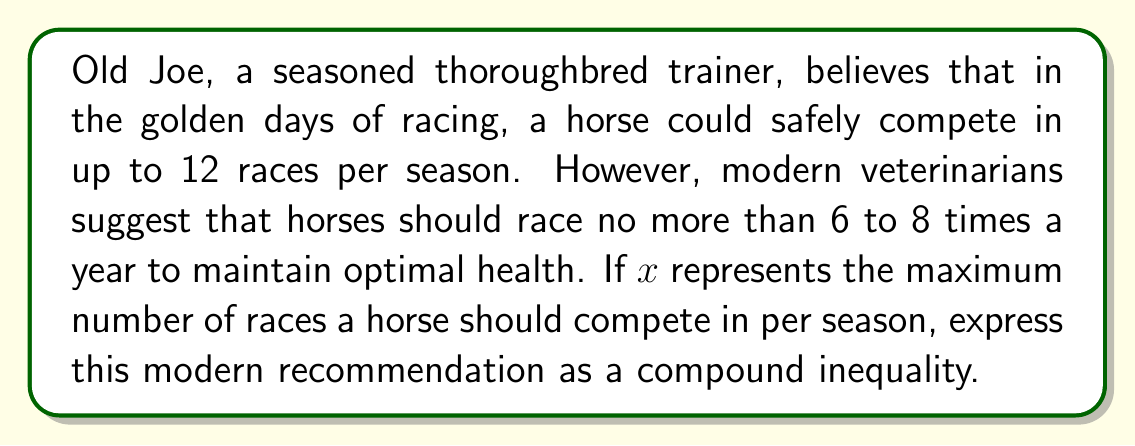Show me your answer to this math problem. To solve this problem, we need to translate the verbal statement into a mathematical inequality:

1. The modern recommendation states that horses should race "no more than 6 to 8 times a year".
2. This means the number of races should be at least 6 but no more than 8.
3. We can represent this as a compound inequality:
   
   $6 \leq x \leq 8$

4. This inequality reads as "x is greater than or equal to 6 AND less than or equal to 8".
5. In this context, $x$ represents the maximum number of races a horse can compete in per season while maintaining health, according to modern recommendations.

This compound inequality effectively captures the range suggested by modern veterinarians, which is more conservative than Old Joe's experience from the "glory days" of racing.
Answer: $6 \leq x \leq 8$, where $x$ is the maximum number of races per season. 